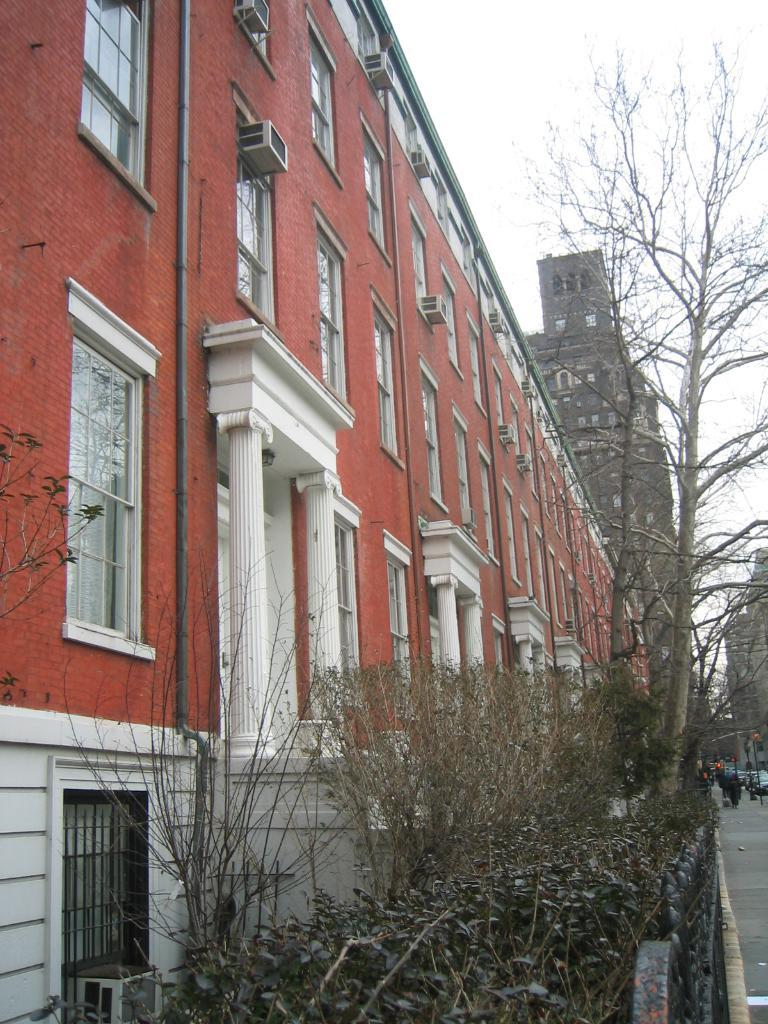What type of structures are present in the image? There are buildings with windows in the image. What architectural features can be seen on the buildings? The buildings have pillars. What type of vegetation is visible in the image? There are plants and trees in the image. What can be seen on the ground in the image? There are people on a pathway in the image. What is visible in the sky in the image? The sky is visible in the image. What type of heart can be seen beating in the image? There is no heart visible in the image; it features buildings, vegetation, and people on a pathway. 